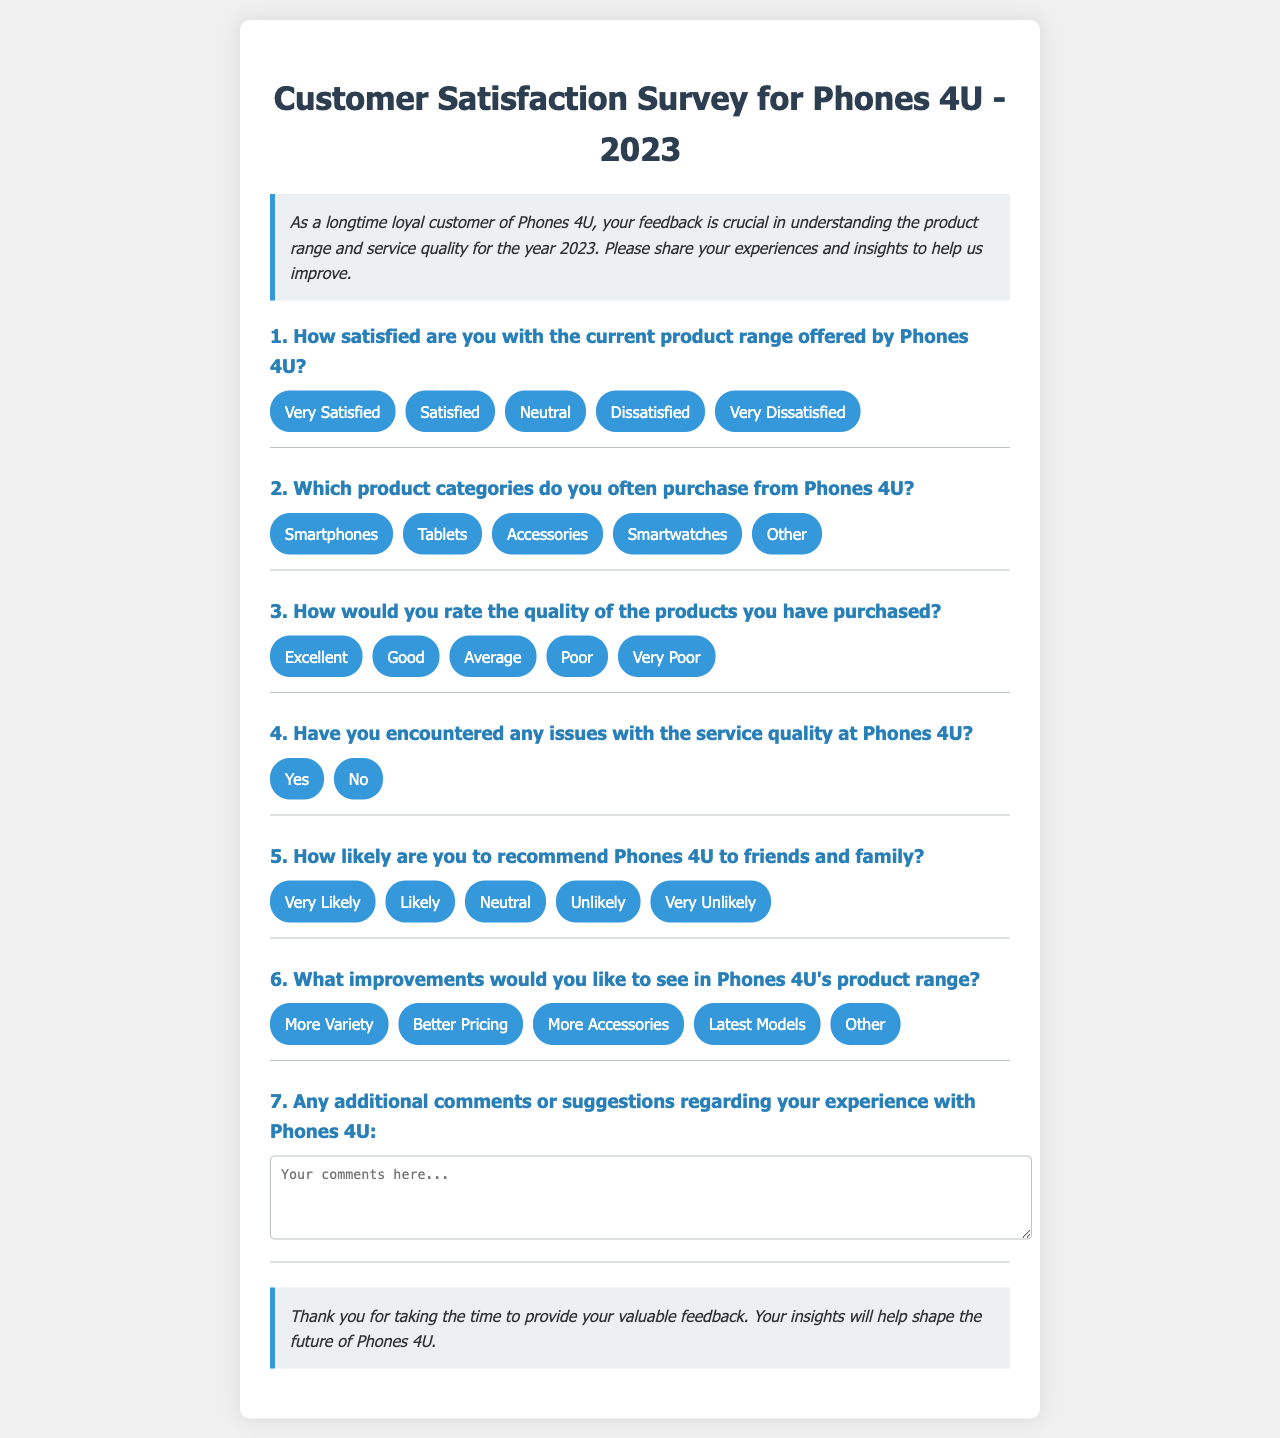What is the title of the survey? The title is "Customer Satisfaction Survey for Phones 4U - 2023".
Answer: Customer Satisfaction Survey for Phones 4U - 2023 What is the main purpose of the survey? The purpose is to gather feedback on product range and service quality for improvement.
Answer: Feedback on product range and service quality How many questions are there in the survey? There are a total of seven questions listed in the document.
Answer: Seven What are the response options for the first question? The options are "Very Satisfied", "Satisfied", "Neutral", "Dissatisfied", "Very Dissatisfied".
Answer: Very Satisfied, Satisfied, Neutral, Dissatisfied, Very Dissatisfied What is the follow-up question related to service quality? The follow-up question is "Please describe the issue:".
Answer: Please describe the issue: Which product category is NOT mentioned as an option for question two? The categories include Smartphones, Tablets, Accessories, and Smartwatches; "Laptops" is not mentioned.
Answer: Laptops What improvement is suggested in question six? The options include "More Variety", "Better Pricing", "More Accessories", "Latest Models", with room for "Other".
Answer: More Variety, Better Pricing, More Accessories, Latest Models, Other What is the closing statement in the survey? The closing statement thanks the participant for their feedback and emphasizes its importance.
Answer: Thank you for taking the time to provide your valuable feedback 